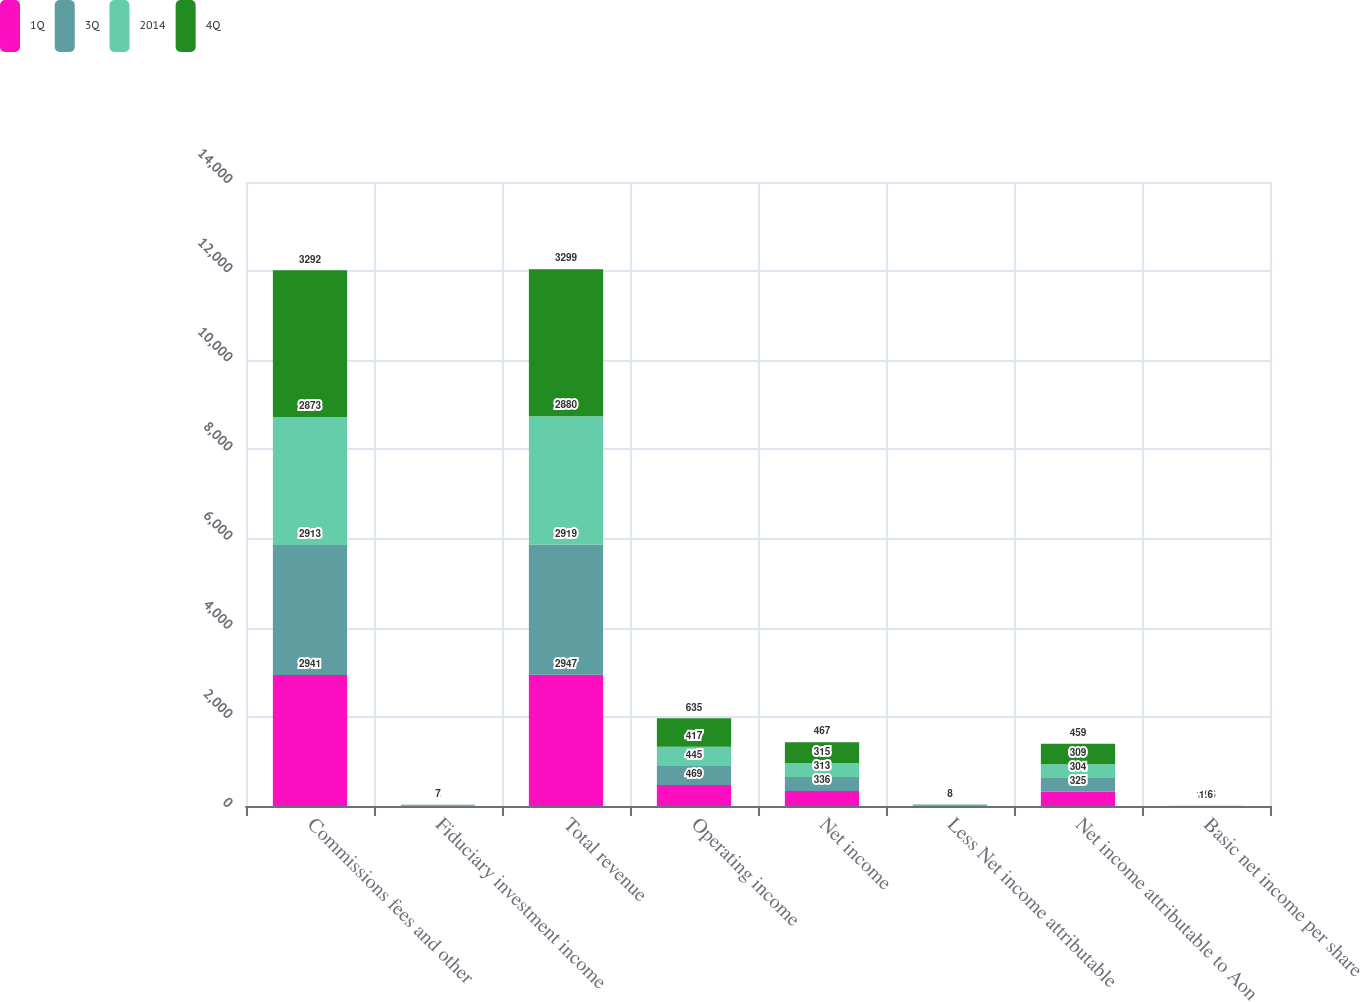<chart> <loc_0><loc_0><loc_500><loc_500><stacked_bar_chart><ecel><fcel>Commissions fees and other<fcel>Fiduciary investment income<fcel>Total revenue<fcel>Operating income<fcel>Net income<fcel>Less Net income attributable<fcel>Net income attributable to Aon<fcel>Basic net income per share<nl><fcel>1Q<fcel>2941<fcel>6<fcel>2947<fcel>469<fcel>336<fcel>11<fcel>325<fcel>1.07<nl><fcel>3Q<fcel>2913<fcel>6<fcel>2919<fcel>445<fcel>313<fcel>9<fcel>304<fcel>1.02<nl><fcel>2014<fcel>2873<fcel>7<fcel>2880<fcel>417<fcel>315<fcel>6<fcel>309<fcel>1.06<nl><fcel>4Q<fcel>3292<fcel>7<fcel>3299<fcel>635<fcel>467<fcel>8<fcel>459<fcel>1.6<nl></chart> 